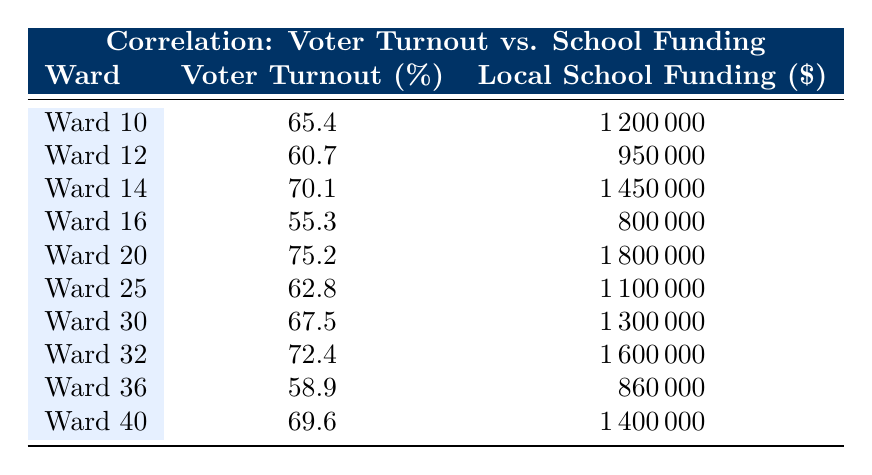What is the voter turnout percentage for Ward 20? Looking at the table, Ward 20 has a voter turnout of 75.2%.
Answer: 75.2 Which ward has the highest local school funding? By reviewing the local school funding column, Ward 20 has the highest amount at $1,800,000.
Answer: Ward 20 How many wards have a voter turnout above 70%? The wards with voter turnout above 70% are Ward 14 (70.1%), Ward 20 (75.2%), and Ward 32 (72.4%), which totals to 3 wards.
Answer: 3 What is the average local school funding of all the wards? To calculate the average, first sum the school funding: 1,200,000 + 950,000 + 1,450,000 + 800,000 + 1,800,000 + 1,100,000 + 1,300,000 + 1,600,000 + 860,000 + 1,400,000 = 11,610,000. There are 10 wards, so the average is 11,610,000 / 10 = 1,161,000.
Answer: 1,161,000 Is there a correlation between higher local school funding and voter turnout based on the table? Observing the table, as local school funding generally increases, most wards have higher voter turnout percentages (e.g., Ward 20 with the highest funding also has the highest turnout), suggesting a possible positive correlation.
Answer: Yes 